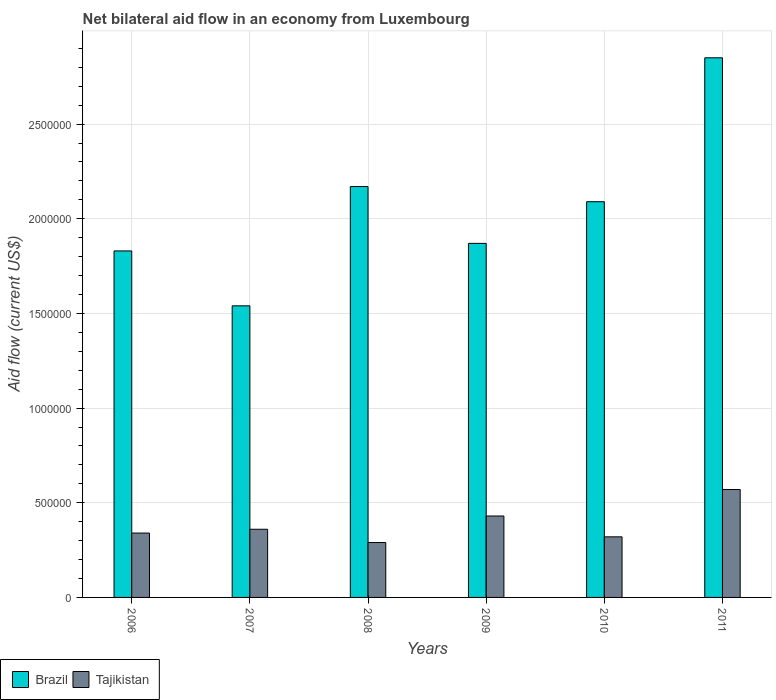How many different coloured bars are there?
Make the answer very short. 2. How many groups of bars are there?
Keep it short and to the point. 6. Are the number of bars on each tick of the X-axis equal?
Offer a terse response. Yes. How many bars are there on the 1st tick from the left?
Provide a short and direct response. 2. What is the label of the 5th group of bars from the left?
Keep it short and to the point. 2010. What is the net bilateral aid flow in Brazil in 2006?
Offer a very short reply. 1.83e+06. Across all years, what is the maximum net bilateral aid flow in Brazil?
Your answer should be compact. 2.85e+06. Across all years, what is the minimum net bilateral aid flow in Brazil?
Ensure brevity in your answer.  1.54e+06. What is the total net bilateral aid flow in Brazil in the graph?
Offer a very short reply. 1.24e+07. What is the difference between the net bilateral aid flow in Brazil in 2006 and that in 2010?
Ensure brevity in your answer.  -2.60e+05. What is the difference between the net bilateral aid flow in Tajikistan in 2008 and the net bilateral aid flow in Brazil in 2006?
Your answer should be very brief. -1.54e+06. What is the average net bilateral aid flow in Brazil per year?
Keep it short and to the point. 2.06e+06. In the year 2011, what is the difference between the net bilateral aid flow in Brazil and net bilateral aid flow in Tajikistan?
Offer a very short reply. 2.28e+06. What is the ratio of the net bilateral aid flow in Brazil in 2006 to that in 2008?
Keep it short and to the point. 0.84. Is the difference between the net bilateral aid flow in Brazil in 2009 and 2011 greater than the difference between the net bilateral aid flow in Tajikistan in 2009 and 2011?
Your answer should be compact. No. What is the difference between the highest and the second highest net bilateral aid flow in Tajikistan?
Give a very brief answer. 1.40e+05. Is the sum of the net bilateral aid flow in Tajikistan in 2009 and 2011 greater than the maximum net bilateral aid flow in Brazil across all years?
Ensure brevity in your answer.  No. What does the 1st bar from the right in 2010 represents?
Your answer should be compact. Tajikistan. How many bars are there?
Provide a short and direct response. 12. Are all the bars in the graph horizontal?
Your answer should be very brief. No. Does the graph contain grids?
Your answer should be compact. Yes. What is the title of the graph?
Provide a succinct answer. Net bilateral aid flow in an economy from Luxembourg. Does "Greenland" appear as one of the legend labels in the graph?
Give a very brief answer. No. What is the Aid flow (current US$) in Brazil in 2006?
Offer a very short reply. 1.83e+06. What is the Aid flow (current US$) in Brazil in 2007?
Provide a short and direct response. 1.54e+06. What is the Aid flow (current US$) in Brazil in 2008?
Your answer should be compact. 2.17e+06. What is the Aid flow (current US$) of Tajikistan in 2008?
Your response must be concise. 2.90e+05. What is the Aid flow (current US$) in Brazil in 2009?
Your answer should be very brief. 1.87e+06. What is the Aid flow (current US$) in Brazil in 2010?
Your answer should be compact. 2.09e+06. What is the Aid flow (current US$) of Brazil in 2011?
Your response must be concise. 2.85e+06. What is the Aid flow (current US$) of Tajikistan in 2011?
Provide a short and direct response. 5.70e+05. Across all years, what is the maximum Aid flow (current US$) of Brazil?
Your response must be concise. 2.85e+06. Across all years, what is the maximum Aid flow (current US$) of Tajikistan?
Give a very brief answer. 5.70e+05. Across all years, what is the minimum Aid flow (current US$) of Brazil?
Your response must be concise. 1.54e+06. What is the total Aid flow (current US$) of Brazil in the graph?
Your response must be concise. 1.24e+07. What is the total Aid flow (current US$) in Tajikistan in the graph?
Offer a terse response. 2.31e+06. What is the difference between the Aid flow (current US$) of Brazil in 2006 and that in 2008?
Keep it short and to the point. -3.40e+05. What is the difference between the Aid flow (current US$) in Brazil in 2006 and that in 2011?
Your response must be concise. -1.02e+06. What is the difference between the Aid flow (current US$) in Tajikistan in 2006 and that in 2011?
Your response must be concise. -2.30e+05. What is the difference between the Aid flow (current US$) of Brazil in 2007 and that in 2008?
Provide a succinct answer. -6.30e+05. What is the difference between the Aid flow (current US$) in Brazil in 2007 and that in 2009?
Your response must be concise. -3.30e+05. What is the difference between the Aid flow (current US$) of Brazil in 2007 and that in 2010?
Keep it short and to the point. -5.50e+05. What is the difference between the Aid flow (current US$) in Brazil in 2007 and that in 2011?
Offer a terse response. -1.31e+06. What is the difference between the Aid flow (current US$) of Tajikistan in 2007 and that in 2011?
Offer a very short reply. -2.10e+05. What is the difference between the Aid flow (current US$) in Tajikistan in 2008 and that in 2009?
Make the answer very short. -1.40e+05. What is the difference between the Aid flow (current US$) of Tajikistan in 2008 and that in 2010?
Your answer should be compact. -3.00e+04. What is the difference between the Aid flow (current US$) in Brazil in 2008 and that in 2011?
Ensure brevity in your answer.  -6.80e+05. What is the difference between the Aid flow (current US$) of Tajikistan in 2008 and that in 2011?
Provide a succinct answer. -2.80e+05. What is the difference between the Aid flow (current US$) in Brazil in 2009 and that in 2010?
Offer a very short reply. -2.20e+05. What is the difference between the Aid flow (current US$) of Brazil in 2009 and that in 2011?
Provide a short and direct response. -9.80e+05. What is the difference between the Aid flow (current US$) of Tajikistan in 2009 and that in 2011?
Make the answer very short. -1.40e+05. What is the difference between the Aid flow (current US$) of Brazil in 2010 and that in 2011?
Ensure brevity in your answer.  -7.60e+05. What is the difference between the Aid flow (current US$) of Brazil in 2006 and the Aid flow (current US$) of Tajikistan in 2007?
Offer a very short reply. 1.47e+06. What is the difference between the Aid flow (current US$) of Brazil in 2006 and the Aid flow (current US$) of Tajikistan in 2008?
Offer a very short reply. 1.54e+06. What is the difference between the Aid flow (current US$) of Brazil in 2006 and the Aid flow (current US$) of Tajikistan in 2009?
Your answer should be very brief. 1.40e+06. What is the difference between the Aid flow (current US$) in Brazil in 2006 and the Aid flow (current US$) in Tajikistan in 2010?
Your answer should be compact. 1.51e+06. What is the difference between the Aid flow (current US$) in Brazil in 2006 and the Aid flow (current US$) in Tajikistan in 2011?
Provide a succinct answer. 1.26e+06. What is the difference between the Aid flow (current US$) in Brazil in 2007 and the Aid flow (current US$) in Tajikistan in 2008?
Offer a very short reply. 1.25e+06. What is the difference between the Aid flow (current US$) of Brazil in 2007 and the Aid flow (current US$) of Tajikistan in 2009?
Offer a very short reply. 1.11e+06. What is the difference between the Aid flow (current US$) in Brazil in 2007 and the Aid flow (current US$) in Tajikistan in 2010?
Provide a succinct answer. 1.22e+06. What is the difference between the Aid flow (current US$) of Brazil in 2007 and the Aid flow (current US$) of Tajikistan in 2011?
Your answer should be compact. 9.70e+05. What is the difference between the Aid flow (current US$) in Brazil in 2008 and the Aid flow (current US$) in Tajikistan in 2009?
Offer a very short reply. 1.74e+06. What is the difference between the Aid flow (current US$) of Brazil in 2008 and the Aid flow (current US$) of Tajikistan in 2010?
Provide a succinct answer. 1.85e+06. What is the difference between the Aid flow (current US$) of Brazil in 2008 and the Aid flow (current US$) of Tajikistan in 2011?
Your response must be concise. 1.60e+06. What is the difference between the Aid flow (current US$) in Brazil in 2009 and the Aid flow (current US$) in Tajikistan in 2010?
Offer a very short reply. 1.55e+06. What is the difference between the Aid flow (current US$) in Brazil in 2009 and the Aid flow (current US$) in Tajikistan in 2011?
Offer a terse response. 1.30e+06. What is the difference between the Aid flow (current US$) in Brazil in 2010 and the Aid flow (current US$) in Tajikistan in 2011?
Give a very brief answer. 1.52e+06. What is the average Aid flow (current US$) in Brazil per year?
Provide a succinct answer. 2.06e+06. What is the average Aid flow (current US$) in Tajikistan per year?
Ensure brevity in your answer.  3.85e+05. In the year 2006, what is the difference between the Aid flow (current US$) of Brazil and Aid flow (current US$) of Tajikistan?
Provide a short and direct response. 1.49e+06. In the year 2007, what is the difference between the Aid flow (current US$) of Brazil and Aid flow (current US$) of Tajikistan?
Your answer should be compact. 1.18e+06. In the year 2008, what is the difference between the Aid flow (current US$) of Brazil and Aid flow (current US$) of Tajikistan?
Make the answer very short. 1.88e+06. In the year 2009, what is the difference between the Aid flow (current US$) of Brazil and Aid flow (current US$) of Tajikistan?
Give a very brief answer. 1.44e+06. In the year 2010, what is the difference between the Aid flow (current US$) of Brazil and Aid flow (current US$) of Tajikistan?
Offer a terse response. 1.77e+06. In the year 2011, what is the difference between the Aid flow (current US$) in Brazil and Aid flow (current US$) in Tajikistan?
Provide a short and direct response. 2.28e+06. What is the ratio of the Aid flow (current US$) in Brazil in 2006 to that in 2007?
Offer a very short reply. 1.19. What is the ratio of the Aid flow (current US$) in Brazil in 2006 to that in 2008?
Your answer should be compact. 0.84. What is the ratio of the Aid flow (current US$) in Tajikistan in 2006 to that in 2008?
Provide a succinct answer. 1.17. What is the ratio of the Aid flow (current US$) of Brazil in 2006 to that in 2009?
Ensure brevity in your answer.  0.98. What is the ratio of the Aid flow (current US$) in Tajikistan in 2006 to that in 2009?
Ensure brevity in your answer.  0.79. What is the ratio of the Aid flow (current US$) in Brazil in 2006 to that in 2010?
Your answer should be compact. 0.88. What is the ratio of the Aid flow (current US$) in Brazil in 2006 to that in 2011?
Offer a terse response. 0.64. What is the ratio of the Aid flow (current US$) in Tajikistan in 2006 to that in 2011?
Ensure brevity in your answer.  0.6. What is the ratio of the Aid flow (current US$) of Brazil in 2007 to that in 2008?
Provide a succinct answer. 0.71. What is the ratio of the Aid flow (current US$) in Tajikistan in 2007 to that in 2008?
Offer a very short reply. 1.24. What is the ratio of the Aid flow (current US$) in Brazil in 2007 to that in 2009?
Give a very brief answer. 0.82. What is the ratio of the Aid flow (current US$) in Tajikistan in 2007 to that in 2009?
Offer a very short reply. 0.84. What is the ratio of the Aid flow (current US$) of Brazil in 2007 to that in 2010?
Provide a short and direct response. 0.74. What is the ratio of the Aid flow (current US$) of Brazil in 2007 to that in 2011?
Keep it short and to the point. 0.54. What is the ratio of the Aid flow (current US$) in Tajikistan in 2007 to that in 2011?
Provide a succinct answer. 0.63. What is the ratio of the Aid flow (current US$) of Brazil in 2008 to that in 2009?
Ensure brevity in your answer.  1.16. What is the ratio of the Aid flow (current US$) of Tajikistan in 2008 to that in 2009?
Your answer should be compact. 0.67. What is the ratio of the Aid flow (current US$) of Brazil in 2008 to that in 2010?
Give a very brief answer. 1.04. What is the ratio of the Aid flow (current US$) in Tajikistan in 2008 to that in 2010?
Offer a terse response. 0.91. What is the ratio of the Aid flow (current US$) of Brazil in 2008 to that in 2011?
Your answer should be very brief. 0.76. What is the ratio of the Aid flow (current US$) of Tajikistan in 2008 to that in 2011?
Your answer should be compact. 0.51. What is the ratio of the Aid flow (current US$) of Brazil in 2009 to that in 2010?
Provide a succinct answer. 0.89. What is the ratio of the Aid flow (current US$) in Tajikistan in 2009 to that in 2010?
Give a very brief answer. 1.34. What is the ratio of the Aid flow (current US$) of Brazil in 2009 to that in 2011?
Make the answer very short. 0.66. What is the ratio of the Aid flow (current US$) in Tajikistan in 2009 to that in 2011?
Provide a succinct answer. 0.75. What is the ratio of the Aid flow (current US$) of Brazil in 2010 to that in 2011?
Your response must be concise. 0.73. What is the ratio of the Aid flow (current US$) in Tajikistan in 2010 to that in 2011?
Your answer should be very brief. 0.56. What is the difference between the highest and the second highest Aid flow (current US$) in Brazil?
Your response must be concise. 6.80e+05. What is the difference between the highest and the second highest Aid flow (current US$) of Tajikistan?
Offer a terse response. 1.40e+05. What is the difference between the highest and the lowest Aid flow (current US$) in Brazil?
Your answer should be very brief. 1.31e+06. 